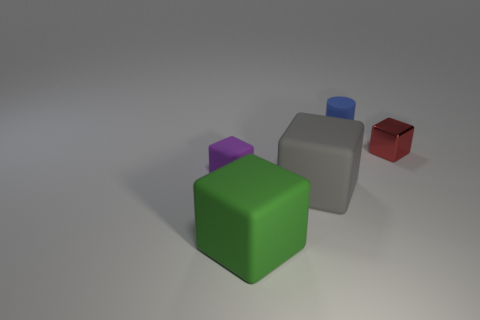Subtract all matte cubes. How many cubes are left? 1 Subtract all purple cubes. How many cubes are left? 3 Add 3 big green matte objects. How many objects exist? 8 Subtract all cubes. How many objects are left? 1 Subtract 3 blocks. How many blocks are left? 1 Add 2 blue cylinders. How many blue cylinders are left? 3 Add 2 green rubber balls. How many green rubber balls exist? 2 Subtract 0 cyan cylinders. How many objects are left? 5 Subtract all purple cubes. Subtract all green spheres. How many cubes are left? 3 Subtract all red cylinders. How many gray blocks are left? 1 